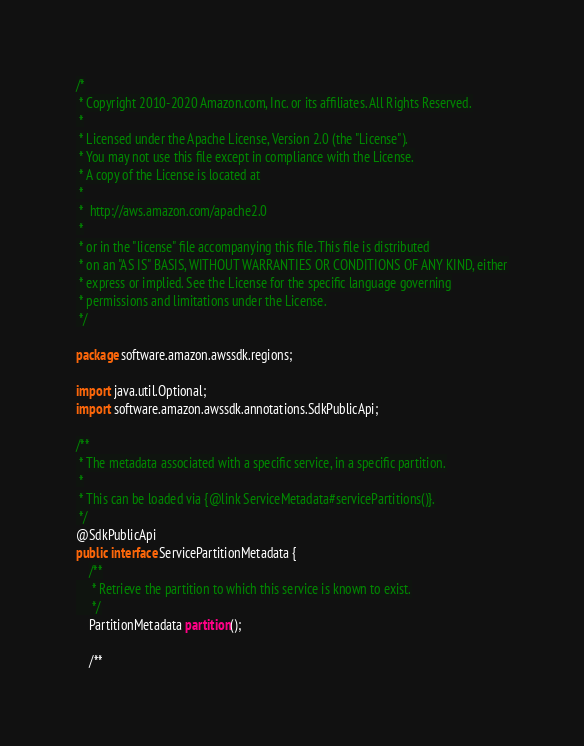Convert code to text. <code><loc_0><loc_0><loc_500><loc_500><_Java_>/*
 * Copyright 2010-2020 Amazon.com, Inc. or its affiliates. All Rights Reserved.
 *
 * Licensed under the Apache License, Version 2.0 (the "License").
 * You may not use this file except in compliance with the License.
 * A copy of the License is located at
 *
 *  http://aws.amazon.com/apache2.0
 *
 * or in the "license" file accompanying this file. This file is distributed
 * on an "AS IS" BASIS, WITHOUT WARRANTIES OR CONDITIONS OF ANY KIND, either
 * express or implied. See the License for the specific language governing
 * permissions and limitations under the License.
 */

package software.amazon.awssdk.regions;

import java.util.Optional;
import software.amazon.awssdk.annotations.SdkPublicApi;

/**
 * The metadata associated with a specific service, in a specific partition.
 *
 * This can be loaded via {@link ServiceMetadata#servicePartitions()}.
 */
@SdkPublicApi
public interface ServicePartitionMetadata {
    /**
     * Retrieve the partition to which this service is known to exist.
     */
    PartitionMetadata partition();

    /**</code> 